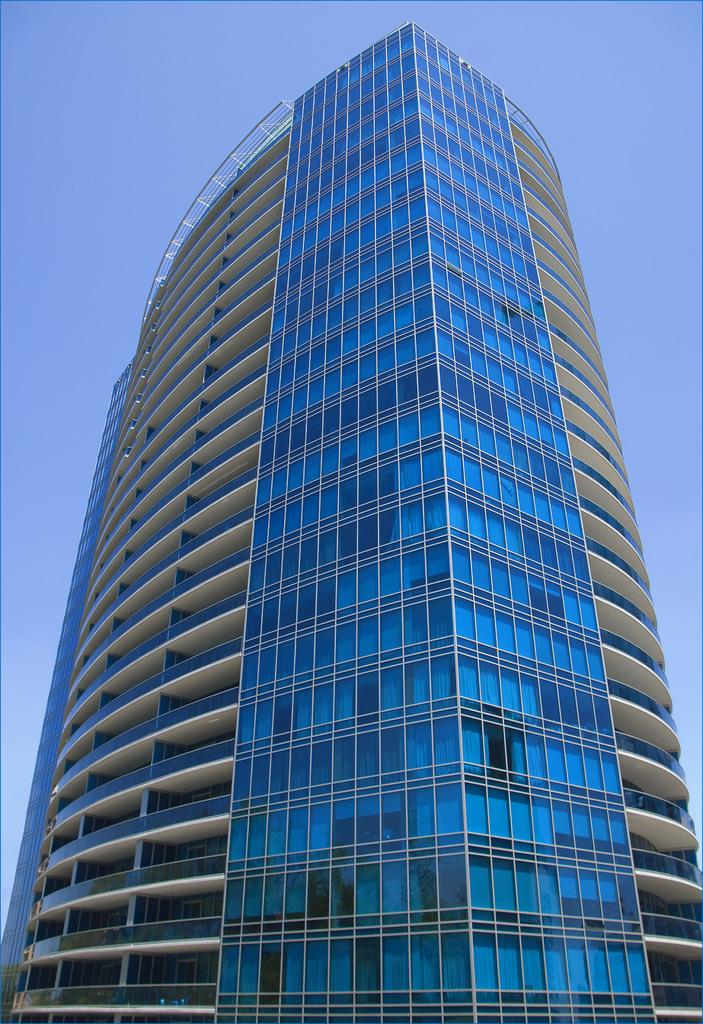What structure is present in the image? There is a building in the image. What part of the natural environment is visible in the image? The sky is visible at the back side of the building in the image. Can you see a snake slithering on the floor of the building in the image? There is no snake present in the image. What type of furniture can be seen in the bedroom of the building in the image? There is no bedroom present in the image, as it only features a building and the sky visible at the back side of the building. 